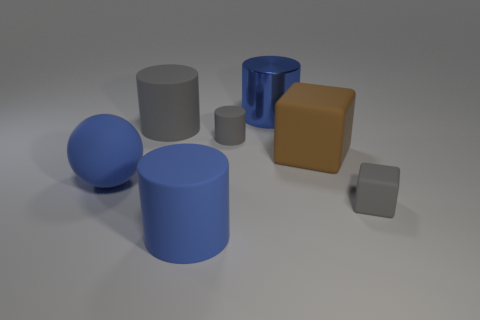What shape is the large matte thing that is the same color as the tiny rubber cylinder?
Make the answer very short. Cylinder. How many gray things are either tiny cylinders or small cubes?
Make the answer very short. 2. Is the size of the blue matte cylinder the same as the matte cube behind the ball?
Provide a short and direct response. Yes. What number of other things are the same size as the rubber sphere?
Offer a terse response. 4. What is the shape of the gray object that is on the left side of the big blue matte cylinder that is right of the blue thing to the left of the large blue rubber cylinder?
Make the answer very short. Cylinder. What shape is the object that is in front of the big blue sphere and left of the gray cube?
Provide a succinct answer. Cylinder. What number of objects are either green blocks or large things that are behind the big brown rubber block?
Provide a succinct answer. 2. What number of other things are there of the same shape as the large shiny thing?
Offer a very short reply. 3. What is the size of the matte cylinder that is both to the left of the tiny cylinder and behind the large brown rubber thing?
Keep it short and to the point. Large. What number of metallic things are either large gray cubes or small gray things?
Offer a terse response. 0. 